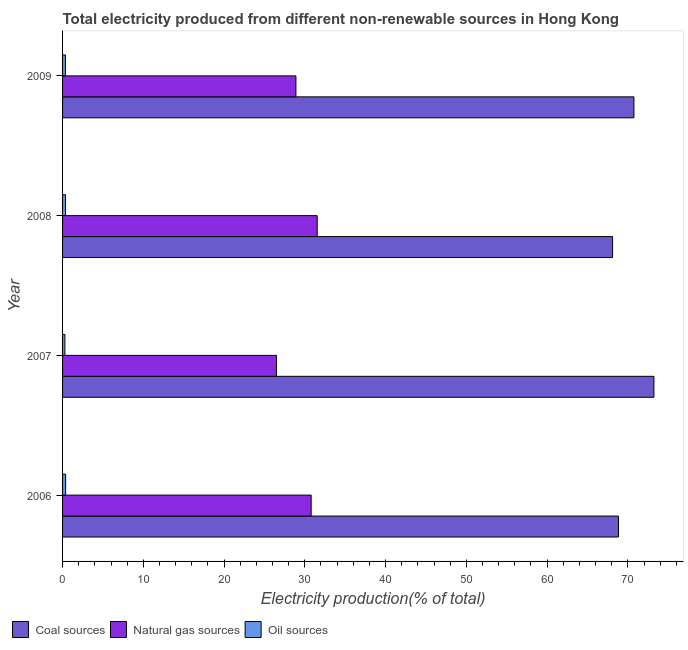How many different coloured bars are there?
Keep it short and to the point. 3. Are the number of bars on each tick of the Y-axis equal?
Keep it short and to the point. Yes. How many bars are there on the 1st tick from the top?
Your answer should be very brief. 3. What is the label of the 3rd group of bars from the top?
Provide a succinct answer. 2007. In how many cases, is the number of bars for a given year not equal to the number of legend labels?
Keep it short and to the point. 0. What is the percentage of electricity produced by coal in 2008?
Give a very brief answer. 68.11. Across all years, what is the maximum percentage of electricity produced by natural gas?
Offer a terse response. 31.53. Across all years, what is the minimum percentage of electricity produced by oil sources?
Provide a succinct answer. 0.29. In which year was the percentage of electricity produced by oil sources maximum?
Provide a succinct answer. 2006. In which year was the percentage of electricity produced by coal minimum?
Provide a succinct answer. 2008. What is the total percentage of electricity produced by oil sources in the graph?
Ensure brevity in your answer.  1.38. What is the difference between the percentage of electricity produced by coal in 2006 and that in 2007?
Offer a terse response. -4.39. What is the difference between the percentage of electricity produced by oil sources in 2009 and the percentage of electricity produced by natural gas in 2008?
Provide a succinct answer. -31.18. What is the average percentage of electricity produced by natural gas per year?
Your answer should be compact. 29.42. In the year 2008, what is the difference between the percentage of electricity produced by coal and percentage of electricity produced by oil sources?
Make the answer very short. 67.75. Is the percentage of electricity produced by coal in 2006 less than that in 2009?
Keep it short and to the point. Yes. Is the difference between the percentage of electricity produced by natural gas in 2007 and 2009 greater than the difference between the percentage of electricity produced by coal in 2007 and 2009?
Your answer should be very brief. No. What is the difference between the highest and the second highest percentage of electricity produced by oil sources?
Offer a terse response. 0.02. What is the difference between the highest and the lowest percentage of electricity produced by coal?
Your response must be concise. 5.12. Is the sum of the percentage of electricity produced by oil sources in 2006 and 2008 greater than the maximum percentage of electricity produced by natural gas across all years?
Your answer should be compact. No. What does the 2nd bar from the top in 2008 represents?
Offer a very short reply. Natural gas sources. What does the 1st bar from the bottom in 2008 represents?
Ensure brevity in your answer.  Coal sources. How many bars are there?
Your answer should be very brief. 12. How many years are there in the graph?
Your response must be concise. 4. Does the graph contain grids?
Keep it short and to the point. No. Where does the legend appear in the graph?
Offer a terse response. Bottom left. How many legend labels are there?
Make the answer very short. 3. How are the legend labels stacked?
Offer a very short reply. Horizontal. What is the title of the graph?
Make the answer very short. Total electricity produced from different non-renewable sources in Hong Kong. Does "Maunufacturing" appear as one of the legend labels in the graph?
Your answer should be compact. No. What is the label or title of the Y-axis?
Make the answer very short. Year. What is the Electricity production(% of total) of Coal sources in 2006?
Provide a short and direct response. 68.84. What is the Electricity production(% of total) of Natural gas sources in 2006?
Provide a succinct answer. 30.78. What is the Electricity production(% of total) in Oil sources in 2006?
Your response must be concise. 0.38. What is the Electricity production(% of total) in Coal sources in 2007?
Offer a terse response. 73.23. What is the Electricity production(% of total) of Natural gas sources in 2007?
Your answer should be very brief. 26.48. What is the Electricity production(% of total) in Oil sources in 2007?
Make the answer very short. 0.29. What is the Electricity production(% of total) in Coal sources in 2008?
Offer a very short reply. 68.11. What is the Electricity production(% of total) of Natural gas sources in 2008?
Your response must be concise. 31.53. What is the Electricity production(% of total) of Oil sources in 2008?
Provide a short and direct response. 0.36. What is the Electricity production(% of total) in Coal sources in 2009?
Your answer should be compact. 70.75. What is the Electricity production(% of total) of Natural gas sources in 2009?
Your answer should be compact. 28.9. What is the Electricity production(% of total) in Oil sources in 2009?
Make the answer very short. 0.35. Across all years, what is the maximum Electricity production(% of total) in Coal sources?
Keep it short and to the point. 73.23. Across all years, what is the maximum Electricity production(% of total) of Natural gas sources?
Your response must be concise. 31.53. Across all years, what is the maximum Electricity production(% of total) of Oil sources?
Keep it short and to the point. 0.38. Across all years, what is the minimum Electricity production(% of total) in Coal sources?
Keep it short and to the point. 68.11. Across all years, what is the minimum Electricity production(% of total) of Natural gas sources?
Give a very brief answer. 26.48. Across all years, what is the minimum Electricity production(% of total) in Oil sources?
Offer a very short reply. 0.29. What is the total Electricity production(% of total) in Coal sources in the graph?
Your answer should be compact. 280.92. What is the total Electricity production(% of total) in Natural gas sources in the graph?
Your answer should be compact. 117.69. What is the total Electricity production(% of total) in Oil sources in the graph?
Your answer should be very brief. 1.38. What is the difference between the Electricity production(% of total) of Coal sources in 2006 and that in 2007?
Provide a short and direct response. -4.39. What is the difference between the Electricity production(% of total) of Natural gas sources in 2006 and that in 2007?
Ensure brevity in your answer.  4.3. What is the difference between the Electricity production(% of total) of Oil sources in 2006 and that in 2007?
Your response must be concise. 0.09. What is the difference between the Electricity production(% of total) in Coal sources in 2006 and that in 2008?
Ensure brevity in your answer.  0.73. What is the difference between the Electricity production(% of total) of Natural gas sources in 2006 and that in 2008?
Your response must be concise. -0.75. What is the difference between the Electricity production(% of total) in Oil sources in 2006 and that in 2008?
Ensure brevity in your answer.  0.02. What is the difference between the Electricity production(% of total) of Coal sources in 2006 and that in 2009?
Your answer should be very brief. -1.91. What is the difference between the Electricity production(% of total) of Natural gas sources in 2006 and that in 2009?
Give a very brief answer. 1.89. What is the difference between the Electricity production(% of total) of Oil sources in 2006 and that in 2009?
Offer a terse response. 0.03. What is the difference between the Electricity production(% of total) in Coal sources in 2007 and that in 2008?
Give a very brief answer. 5.12. What is the difference between the Electricity production(% of total) of Natural gas sources in 2007 and that in 2008?
Ensure brevity in your answer.  -5.05. What is the difference between the Electricity production(% of total) of Oil sources in 2007 and that in 2008?
Offer a very short reply. -0.07. What is the difference between the Electricity production(% of total) of Coal sources in 2007 and that in 2009?
Keep it short and to the point. 2.48. What is the difference between the Electricity production(% of total) in Natural gas sources in 2007 and that in 2009?
Make the answer very short. -2.41. What is the difference between the Electricity production(% of total) of Oil sources in 2007 and that in 2009?
Your answer should be compact. -0.06. What is the difference between the Electricity production(% of total) of Coal sources in 2008 and that in 2009?
Your answer should be compact. -2.64. What is the difference between the Electricity production(% of total) in Natural gas sources in 2008 and that in 2009?
Ensure brevity in your answer.  2.64. What is the difference between the Electricity production(% of total) of Oil sources in 2008 and that in 2009?
Keep it short and to the point. 0.01. What is the difference between the Electricity production(% of total) in Coal sources in 2006 and the Electricity production(% of total) in Natural gas sources in 2007?
Ensure brevity in your answer.  42.35. What is the difference between the Electricity production(% of total) of Coal sources in 2006 and the Electricity production(% of total) of Oil sources in 2007?
Your response must be concise. 68.55. What is the difference between the Electricity production(% of total) of Natural gas sources in 2006 and the Electricity production(% of total) of Oil sources in 2007?
Provide a succinct answer. 30.49. What is the difference between the Electricity production(% of total) in Coal sources in 2006 and the Electricity production(% of total) in Natural gas sources in 2008?
Your answer should be compact. 37.31. What is the difference between the Electricity production(% of total) of Coal sources in 2006 and the Electricity production(% of total) of Oil sources in 2008?
Your answer should be compact. 68.48. What is the difference between the Electricity production(% of total) of Natural gas sources in 2006 and the Electricity production(% of total) of Oil sources in 2008?
Offer a very short reply. 30.42. What is the difference between the Electricity production(% of total) in Coal sources in 2006 and the Electricity production(% of total) in Natural gas sources in 2009?
Make the answer very short. 39.94. What is the difference between the Electricity production(% of total) in Coal sources in 2006 and the Electricity production(% of total) in Oil sources in 2009?
Give a very brief answer. 68.49. What is the difference between the Electricity production(% of total) of Natural gas sources in 2006 and the Electricity production(% of total) of Oil sources in 2009?
Provide a short and direct response. 30.43. What is the difference between the Electricity production(% of total) in Coal sources in 2007 and the Electricity production(% of total) in Natural gas sources in 2008?
Keep it short and to the point. 41.69. What is the difference between the Electricity production(% of total) of Coal sources in 2007 and the Electricity production(% of total) of Oil sources in 2008?
Keep it short and to the point. 72.87. What is the difference between the Electricity production(% of total) of Natural gas sources in 2007 and the Electricity production(% of total) of Oil sources in 2008?
Offer a terse response. 26.12. What is the difference between the Electricity production(% of total) in Coal sources in 2007 and the Electricity production(% of total) in Natural gas sources in 2009?
Your answer should be compact. 44.33. What is the difference between the Electricity production(% of total) in Coal sources in 2007 and the Electricity production(% of total) in Oil sources in 2009?
Make the answer very short. 72.87. What is the difference between the Electricity production(% of total) in Natural gas sources in 2007 and the Electricity production(% of total) in Oil sources in 2009?
Keep it short and to the point. 26.13. What is the difference between the Electricity production(% of total) in Coal sources in 2008 and the Electricity production(% of total) in Natural gas sources in 2009?
Ensure brevity in your answer.  39.21. What is the difference between the Electricity production(% of total) in Coal sources in 2008 and the Electricity production(% of total) in Oil sources in 2009?
Offer a very short reply. 67.75. What is the difference between the Electricity production(% of total) in Natural gas sources in 2008 and the Electricity production(% of total) in Oil sources in 2009?
Offer a terse response. 31.18. What is the average Electricity production(% of total) in Coal sources per year?
Your answer should be very brief. 70.23. What is the average Electricity production(% of total) in Natural gas sources per year?
Keep it short and to the point. 29.42. What is the average Electricity production(% of total) of Oil sources per year?
Give a very brief answer. 0.34. In the year 2006, what is the difference between the Electricity production(% of total) of Coal sources and Electricity production(% of total) of Natural gas sources?
Keep it short and to the point. 38.06. In the year 2006, what is the difference between the Electricity production(% of total) in Coal sources and Electricity production(% of total) in Oil sources?
Your answer should be compact. 68.46. In the year 2006, what is the difference between the Electricity production(% of total) of Natural gas sources and Electricity production(% of total) of Oil sources?
Provide a succinct answer. 30.4. In the year 2007, what is the difference between the Electricity production(% of total) of Coal sources and Electricity production(% of total) of Natural gas sources?
Give a very brief answer. 46.74. In the year 2007, what is the difference between the Electricity production(% of total) in Coal sources and Electricity production(% of total) in Oil sources?
Give a very brief answer. 72.94. In the year 2007, what is the difference between the Electricity production(% of total) in Natural gas sources and Electricity production(% of total) in Oil sources?
Provide a short and direct response. 26.2. In the year 2008, what is the difference between the Electricity production(% of total) of Coal sources and Electricity production(% of total) of Natural gas sources?
Offer a very short reply. 36.57. In the year 2008, what is the difference between the Electricity production(% of total) of Coal sources and Electricity production(% of total) of Oil sources?
Your response must be concise. 67.74. In the year 2008, what is the difference between the Electricity production(% of total) in Natural gas sources and Electricity production(% of total) in Oil sources?
Ensure brevity in your answer.  31.17. In the year 2009, what is the difference between the Electricity production(% of total) in Coal sources and Electricity production(% of total) in Natural gas sources?
Make the answer very short. 41.85. In the year 2009, what is the difference between the Electricity production(% of total) in Coal sources and Electricity production(% of total) in Oil sources?
Offer a very short reply. 70.4. In the year 2009, what is the difference between the Electricity production(% of total) of Natural gas sources and Electricity production(% of total) of Oil sources?
Keep it short and to the point. 28.54. What is the ratio of the Electricity production(% of total) in Coal sources in 2006 to that in 2007?
Your answer should be very brief. 0.94. What is the ratio of the Electricity production(% of total) of Natural gas sources in 2006 to that in 2007?
Keep it short and to the point. 1.16. What is the ratio of the Electricity production(% of total) in Oil sources in 2006 to that in 2007?
Provide a short and direct response. 1.31. What is the ratio of the Electricity production(% of total) of Coal sources in 2006 to that in 2008?
Your response must be concise. 1.01. What is the ratio of the Electricity production(% of total) in Natural gas sources in 2006 to that in 2008?
Make the answer very short. 0.98. What is the ratio of the Electricity production(% of total) in Oil sources in 2006 to that in 2008?
Your response must be concise. 1.05. What is the ratio of the Electricity production(% of total) of Coal sources in 2006 to that in 2009?
Keep it short and to the point. 0.97. What is the ratio of the Electricity production(% of total) in Natural gas sources in 2006 to that in 2009?
Provide a succinct answer. 1.07. What is the ratio of the Electricity production(% of total) in Oil sources in 2006 to that in 2009?
Provide a succinct answer. 1.08. What is the ratio of the Electricity production(% of total) of Coal sources in 2007 to that in 2008?
Offer a terse response. 1.08. What is the ratio of the Electricity production(% of total) of Natural gas sources in 2007 to that in 2008?
Ensure brevity in your answer.  0.84. What is the ratio of the Electricity production(% of total) in Oil sources in 2007 to that in 2008?
Your response must be concise. 0.8. What is the ratio of the Electricity production(% of total) of Coal sources in 2007 to that in 2009?
Provide a succinct answer. 1.03. What is the ratio of the Electricity production(% of total) in Natural gas sources in 2007 to that in 2009?
Ensure brevity in your answer.  0.92. What is the ratio of the Electricity production(% of total) of Oil sources in 2007 to that in 2009?
Provide a succinct answer. 0.82. What is the ratio of the Electricity production(% of total) in Coal sources in 2008 to that in 2009?
Make the answer very short. 0.96. What is the ratio of the Electricity production(% of total) in Natural gas sources in 2008 to that in 2009?
Your answer should be compact. 1.09. What is the ratio of the Electricity production(% of total) of Oil sources in 2008 to that in 2009?
Your response must be concise. 1.03. What is the difference between the highest and the second highest Electricity production(% of total) of Coal sources?
Give a very brief answer. 2.48. What is the difference between the highest and the second highest Electricity production(% of total) in Natural gas sources?
Provide a succinct answer. 0.75. What is the difference between the highest and the second highest Electricity production(% of total) in Oil sources?
Keep it short and to the point. 0.02. What is the difference between the highest and the lowest Electricity production(% of total) of Coal sources?
Your answer should be compact. 5.12. What is the difference between the highest and the lowest Electricity production(% of total) of Natural gas sources?
Offer a terse response. 5.05. What is the difference between the highest and the lowest Electricity production(% of total) of Oil sources?
Offer a very short reply. 0.09. 